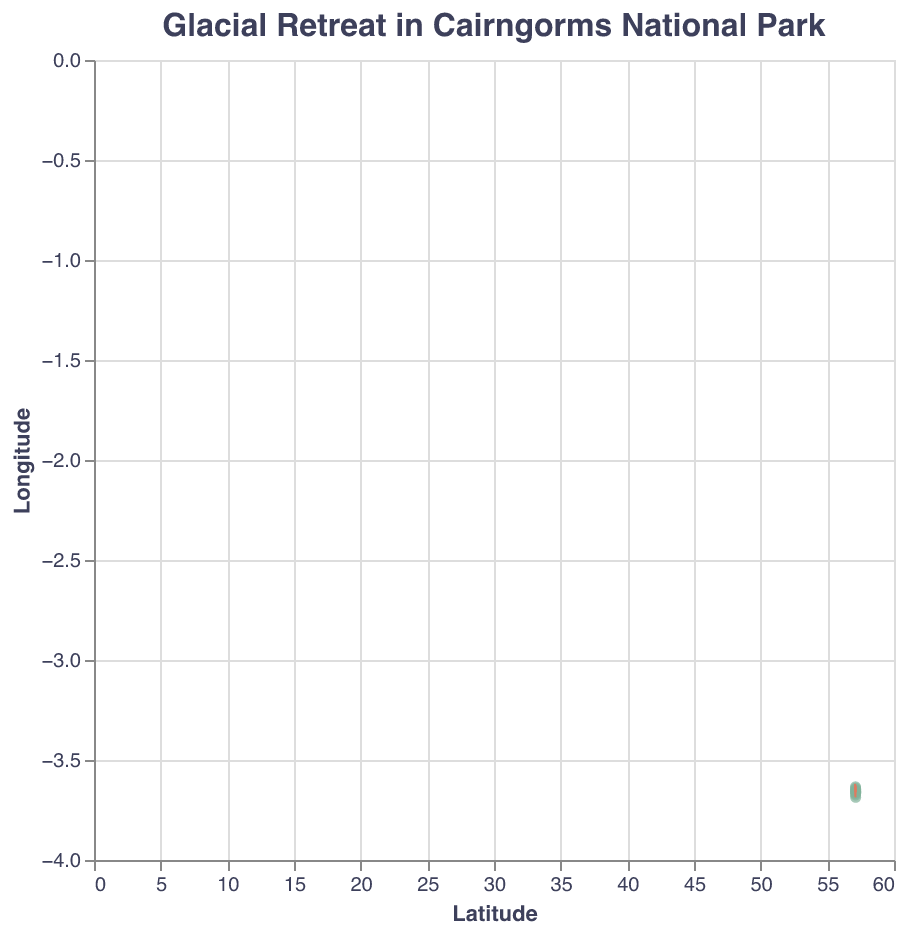How many data points are present in the plot? The plot shows ten markers corresponding to the data points provided in the dataset. Each point represents a specific latitude and longitude.
Answer: 10 What is the title of the plot? The title is prominently displayed at the top of the plot and reads "Glacial Retreat in Cairngorms National Park."
Answer: Glacial Retreat in Cairngorms National Park Which color is used for the markers in the plot? The markers, which represent the points in the plot, are colored in green.
Answer: Green Identify the latitude and longitude of the point with the highest retreat rate. From the plot, each marker has tooltip information showing the retreat rate. The point with the highest magnitude (2.7) is located at latitude 57.141 and longitude -3.663.
Answer: 57.141, -3.663 Which direction do the majority of the data points indicate for the glacial retreat? Examining the quiver arrows, most point towards the upper-left direction, indicating a general northwest retreat direction.
Answer: Northwest What is the average magnitude of the retreat rates across all data points? Sum up all the magnitudes (2.1 + 1.8 + 2.3 + 2.5 + 1.6 + 2.0 + 2.7 + 2.2 + 1.9 + 2.1) and divide by the number of data points (10). The average magnitude is (2.1 + 1.8 + 2.3 + 2.5 + 1.6 + 2.0 + 2.7 + 2.2 + 1.9 + 2.1) / 10 = 2.12.
Answer: 2.12 Compare the retreat rates at latitude 57.127 and latitude 57.113. Which one is greater? The retreat rate at latitude 57.127 is 2.0, and at latitude 57.113, it is 1.9. So, the retreat rate at 57.127 is greater.
Answer: 57.127 What are the x and y labels on the axis? The x-axis is labeled "Latitude," and the y-axis is labeled "Longitude," as indicated on the respective axes of the plot.
Answer: Latitude, Longitude Identify the data point with the smallest retreat rate. What are its coordinates and rate? The smallest retreat rate is 1.6. It corresponds to the data point at coordinates 57.119, -3.675.
Answer: 57.119, -3.675, 1.6 How does the retreat rate at 57.132, -3.659 compare to that at 57.108, -3.652? The retreat rate at 57.132, -3.659 is 2.5, whereas it is 1.8 at 57.108, -3.652. The retreat rate at 57.132, -3.659 is greater.
Answer: 57.132, -3.659 